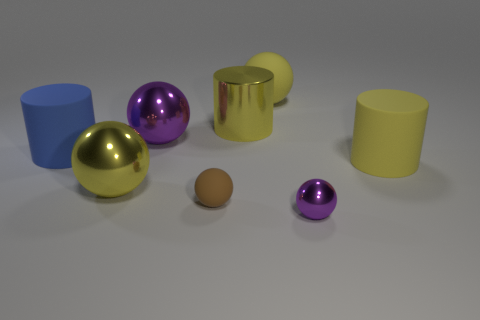What is the size of the blue object that is the same material as the brown thing?
Your answer should be compact. Large. There is a big shiny object in front of the big yellow matte cylinder; is it the same color as the thing in front of the small brown matte thing?
Ensure brevity in your answer.  No. There is a purple ball that is behind the yellow matte cylinder; what number of rubber spheres are behind it?
Offer a terse response. 1. Are any big blue matte things visible?
Make the answer very short. Yes. How many other objects are there of the same color as the tiny matte ball?
Make the answer very short. 0. Are there fewer metallic things than rubber balls?
Give a very brief answer. No. What shape is the big shiny object in front of the yellow rubber thing that is in front of the large yellow shiny cylinder?
Your answer should be very brief. Sphere. Are there any large purple metallic balls behind the metal cylinder?
Your answer should be compact. No. There is a rubber sphere that is the same size as the blue thing; what is its color?
Offer a very short reply. Yellow. What number of large yellow objects are made of the same material as the big purple thing?
Your answer should be very brief. 2. 